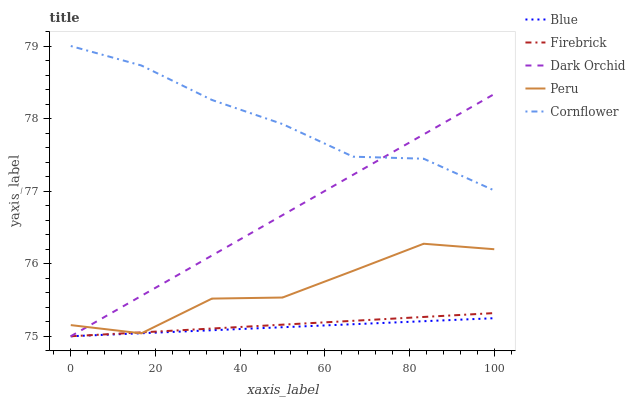Does Blue have the minimum area under the curve?
Answer yes or no. Yes. Does Cornflower have the maximum area under the curve?
Answer yes or no. Yes. Does Firebrick have the minimum area under the curve?
Answer yes or no. No. Does Firebrick have the maximum area under the curve?
Answer yes or no. No. Is Firebrick the smoothest?
Answer yes or no. Yes. Is Peru the roughest?
Answer yes or no. Yes. Is Cornflower the smoothest?
Answer yes or no. No. Is Cornflower the roughest?
Answer yes or no. No. Does Blue have the lowest value?
Answer yes or no. Yes. Does Cornflower have the lowest value?
Answer yes or no. No. Does Cornflower have the highest value?
Answer yes or no. Yes. Does Firebrick have the highest value?
Answer yes or no. No. Is Firebrick less than Cornflower?
Answer yes or no. Yes. Is Cornflower greater than Blue?
Answer yes or no. Yes. Does Firebrick intersect Blue?
Answer yes or no. Yes. Is Firebrick less than Blue?
Answer yes or no. No. Is Firebrick greater than Blue?
Answer yes or no. No. Does Firebrick intersect Cornflower?
Answer yes or no. No. 